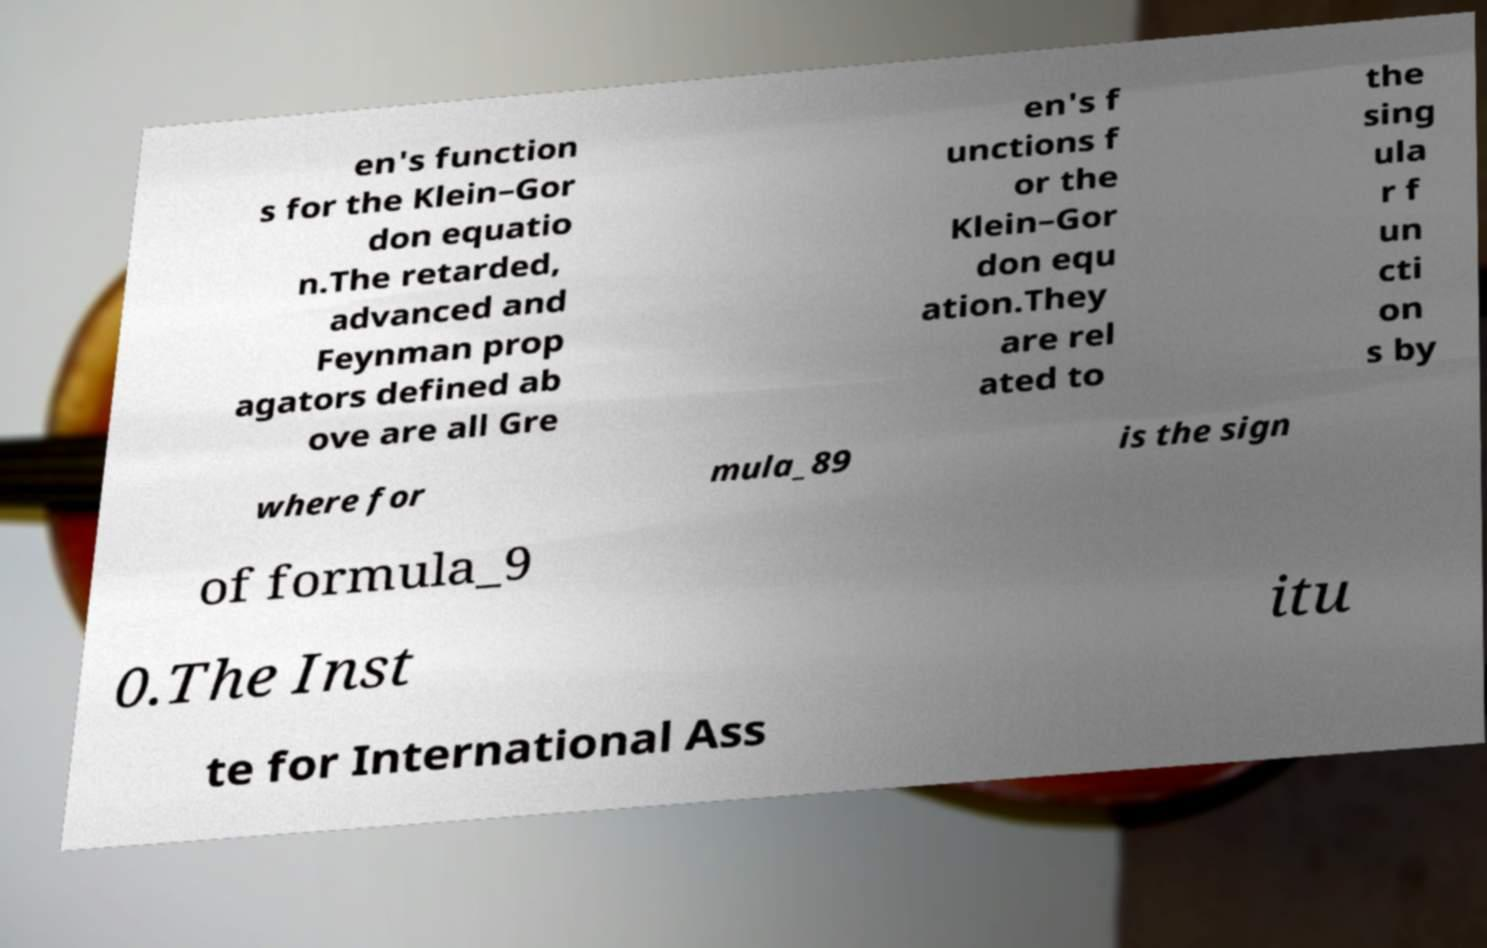Could you assist in decoding the text presented in this image and type it out clearly? en's function s for the Klein–Gor don equatio n.The retarded, advanced and Feynman prop agators defined ab ove are all Gre en's f unctions f or the Klein–Gor don equ ation.They are rel ated to the sing ula r f un cti on s by where for mula_89 is the sign of formula_9 0.The Inst itu te for International Ass 